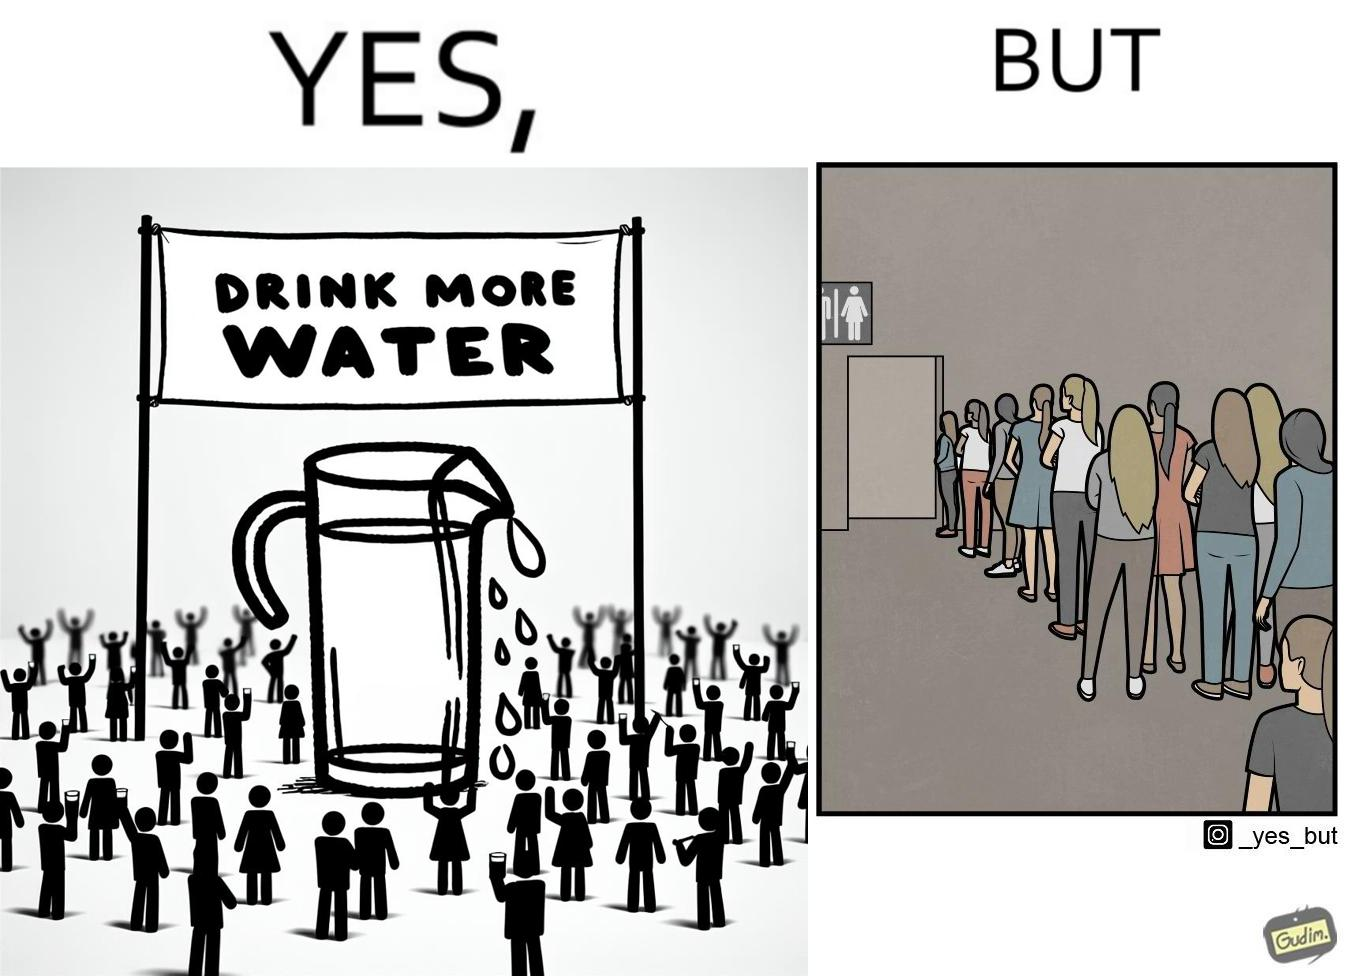What is shown in the left half versus the right half of this image? In the left part of the image: A banner that says "Drink more water" with an image of a jug pouring water into a glass. In the right part of the image: a very long queue in front of the public toilet 